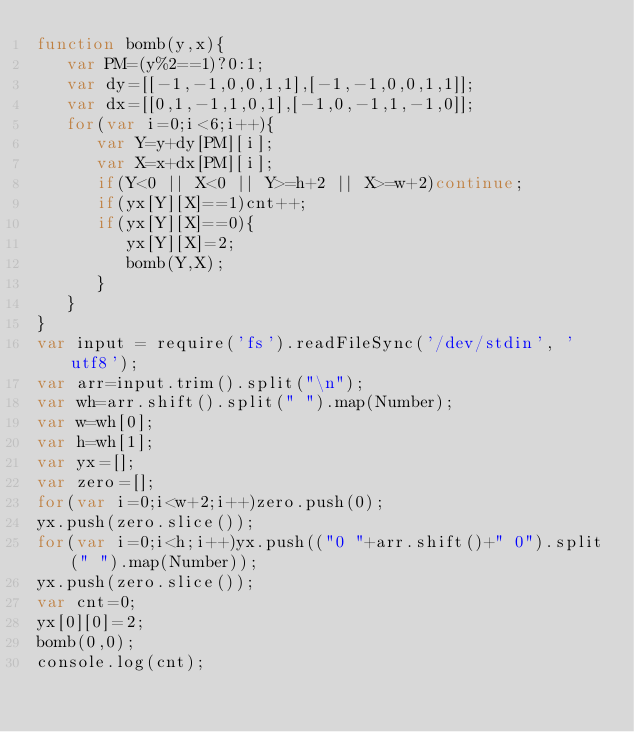<code> <loc_0><loc_0><loc_500><loc_500><_JavaScript_>function bomb(y,x){
   var PM=(y%2==1)?0:1;
   var dy=[[-1,-1,0,0,1,1],[-1,-1,0,0,1,1]];
   var dx=[[0,1,-1,1,0,1],[-1,0,-1,1,-1,0]];
   for(var i=0;i<6;i++){
      var Y=y+dy[PM][i];
      var X=x+dx[PM][i];
      if(Y<0 || X<0 || Y>=h+2 || X>=w+2)continue;
      if(yx[Y][X]==1)cnt++;
      if(yx[Y][X]==0){
         yx[Y][X]=2;
         bomb(Y,X);
      }
   }
}
var input = require('fs').readFileSync('/dev/stdin', 'utf8');
var arr=input.trim().split("\n");
var wh=arr.shift().split(" ").map(Number);
var w=wh[0];
var h=wh[1];
var yx=[];
var zero=[];
for(var i=0;i<w+2;i++)zero.push(0);
yx.push(zero.slice());
for(var i=0;i<h;i++)yx.push(("0 "+arr.shift()+" 0").split(" ").map(Number));
yx.push(zero.slice());
var cnt=0;
yx[0][0]=2;
bomb(0,0);
console.log(cnt);</code> 